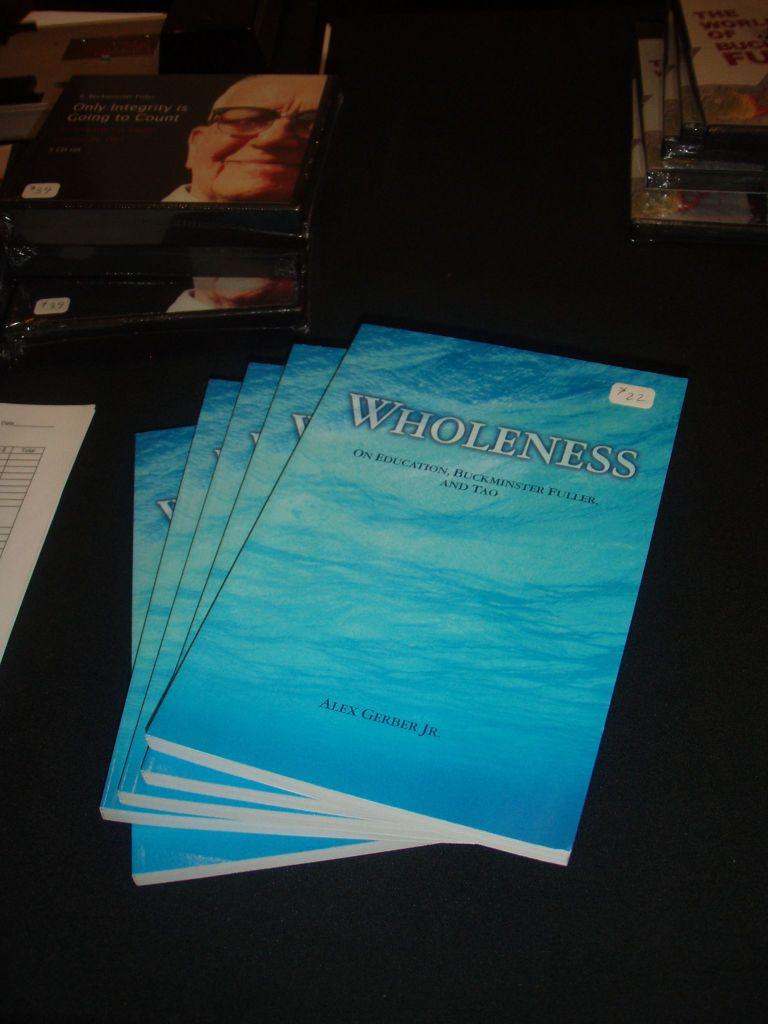Who is the author of this phamplet?
Give a very brief answer. Alex gerber jr. What is the pamphlet title?
Provide a short and direct response. Wholeness. 